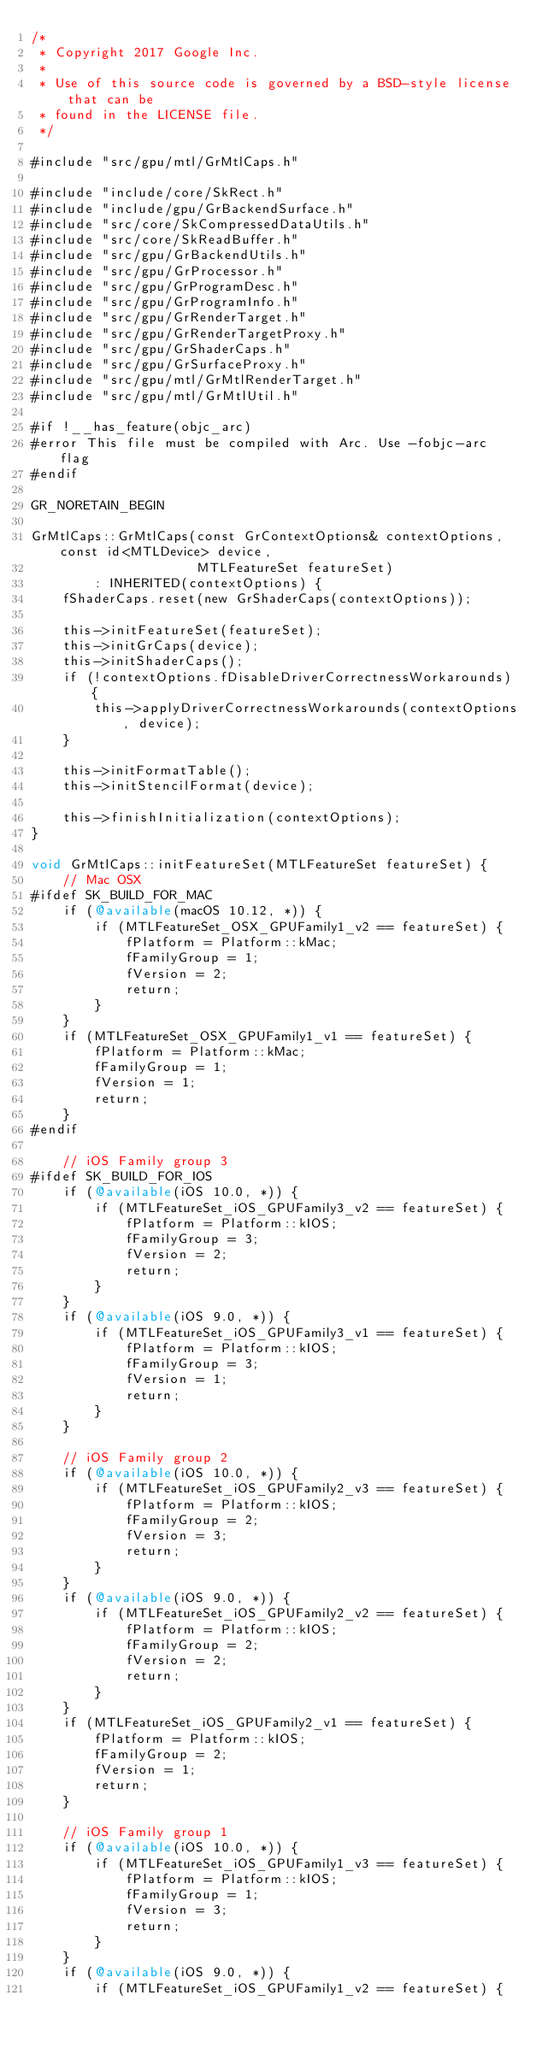Convert code to text. <code><loc_0><loc_0><loc_500><loc_500><_ObjectiveC_>/*
 * Copyright 2017 Google Inc.
 *
 * Use of this source code is governed by a BSD-style license that can be
 * found in the LICENSE file.
 */

#include "src/gpu/mtl/GrMtlCaps.h"

#include "include/core/SkRect.h"
#include "include/gpu/GrBackendSurface.h"
#include "src/core/SkCompressedDataUtils.h"
#include "src/core/SkReadBuffer.h"
#include "src/gpu/GrBackendUtils.h"
#include "src/gpu/GrProcessor.h"
#include "src/gpu/GrProgramDesc.h"
#include "src/gpu/GrProgramInfo.h"
#include "src/gpu/GrRenderTarget.h"
#include "src/gpu/GrRenderTargetProxy.h"
#include "src/gpu/GrShaderCaps.h"
#include "src/gpu/GrSurfaceProxy.h"
#include "src/gpu/mtl/GrMtlRenderTarget.h"
#include "src/gpu/mtl/GrMtlUtil.h"

#if !__has_feature(objc_arc)
#error This file must be compiled with Arc. Use -fobjc-arc flag
#endif

GR_NORETAIN_BEGIN

GrMtlCaps::GrMtlCaps(const GrContextOptions& contextOptions, const id<MTLDevice> device,
                     MTLFeatureSet featureSet)
        : INHERITED(contextOptions) {
    fShaderCaps.reset(new GrShaderCaps(contextOptions));

    this->initFeatureSet(featureSet);
    this->initGrCaps(device);
    this->initShaderCaps();
    if (!contextOptions.fDisableDriverCorrectnessWorkarounds) {
        this->applyDriverCorrectnessWorkarounds(contextOptions, device);
    }

    this->initFormatTable();
    this->initStencilFormat(device);

    this->finishInitialization(contextOptions);
}

void GrMtlCaps::initFeatureSet(MTLFeatureSet featureSet) {
    // Mac OSX
#ifdef SK_BUILD_FOR_MAC
    if (@available(macOS 10.12, *)) {
        if (MTLFeatureSet_OSX_GPUFamily1_v2 == featureSet) {
            fPlatform = Platform::kMac;
            fFamilyGroup = 1;
            fVersion = 2;
            return;
        }
    }
    if (MTLFeatureSet_OSX_GPUFamily1_v1 == featureSet) {
        fPlatform = Platform::kMac;
        fFamilyGroup = 1;
        fVersion = 1;
        return;
    }
#endif

    // iOS Family group 3
#ifdef SK_BUILD_FOR_IOS
    if (@available(iOS 10.0, *)) {
        if (MTLFeatureSet_iOS_GPUFamily3_v2 == featureSet) {
            fPlatform = Platform::kIOS;
            fFamilyGroup = 3;
            fVersion = 2;
            return;
        }
    }
    if (@available(iOS 9.0, *)) {
        if (MTLFeatureSet_iOS_GPUFamily3_v1 == featureSet) {
            fPlatform = Platform::kIOS;
            fFamilyGroup = 3;
            fVersion = 1;
            return;
        }
    }

    // iOS Family group 2
    if (@available(iOS 10.0, *)) {
        if (MTLFeatureSet_iOS_GPUFamily2_v3 == featureSet) {
            fPlatform = Platform::kIOS;
            fFamilyGroup = 2;
            fVersion = 3;
            return;
        }
    }
    if (@available(iOS 9.0, *)) {
        if (MTLFeatureSet_iOS_GPUFamily2_v2 == featureSet) {
            fPlatform = Platform::kIOS;
            fFamilyGroup = 2;
            fVersion = 2;
            return;
        }
    }
    if (MTLFeatureSet_iOS_GPUFamily2_v1 == featureSet) {
        fPlatform = Platform::kIOS;
        fFamilyGroup = 2;
        fVersion = 1;
        return;
    }

    // iOS Family group 1
    if (@available(iOS 10.0, *)) {
        if (MTLFeatureSet_iOS_GPUFamily1_v3 == featureSet) {
            fPlatform = Platform::kIOS;
            fFamilyGroup = 1;
            fVersion = 3;
            return;
        }
    }
    if (@available(iOS 9.0, *)) {
        if (MTLFeatureSet_iOS_GPUFamily1_v2 == featureSet) {</code> 